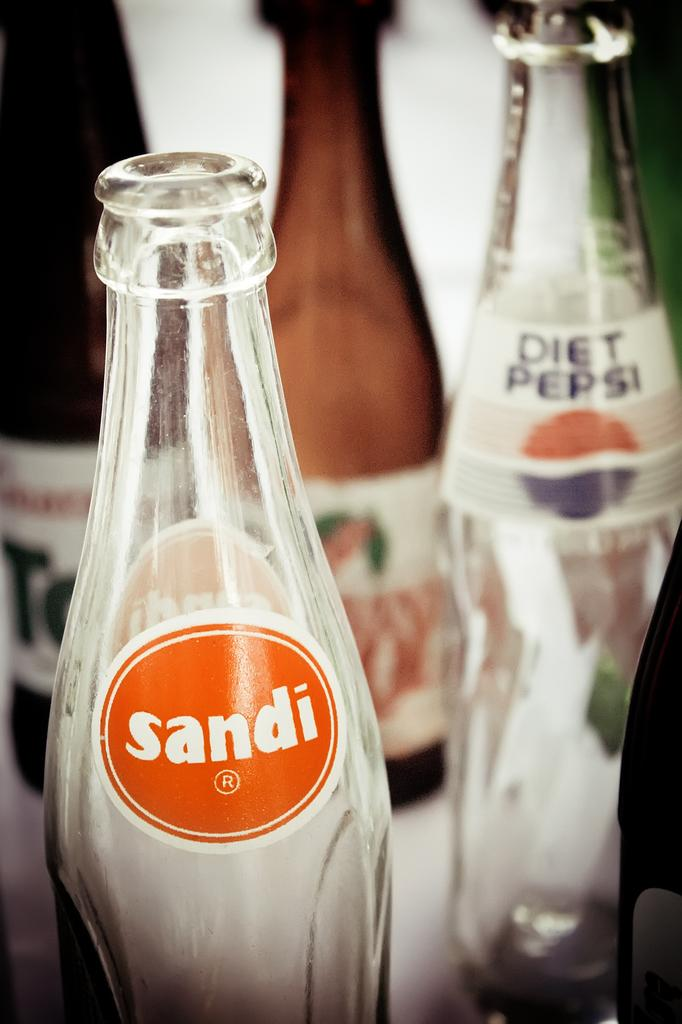<image>
Summarize the visual content of the image. Empty bottles of which one is called Sandi and the other is called Diet Pepsi. 